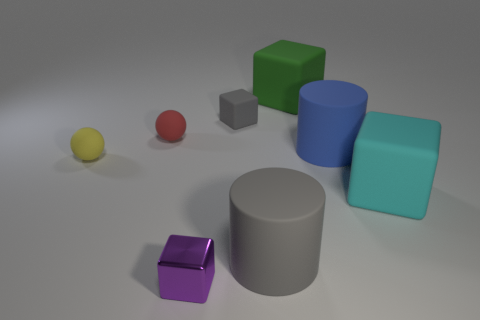Are there any other things that are the same color as the small metallic block?
Your response must be concise. No. What is the sphere that is behind the rubber cylinder that is on the right side of the large matte cylinder on the left side of the large green block made of?
Your answer should be compact. Rubber. What number of metal things are either small red spheres or big yellow cylinders?
Your response must be concise. 0. Does the shiny cube have the same color as the tiny rubber block?
Make the answer very short. No. Is there anything else that has the same material as the tiny purple cube?
Your answer should be very brief. No. What number of things are either tiny purple shiny cubes or small balls on the left side of the small red matte thing?
Your response must be concise. 2. There is a block right of the green rubber cube; is its size the same as the gray matte cylinder?
Your answer should be compact. Yes. What number of other things are there of the same shape as the cyan thing?
Give a very brief answer. 3. What number of gray objects are big cylinders or large cubes?
Your response must be concise. 1. There is a large block that is in front of the large green rubber block; does it have the same color as the small rubber cube?
Give a very brief answer. No. 